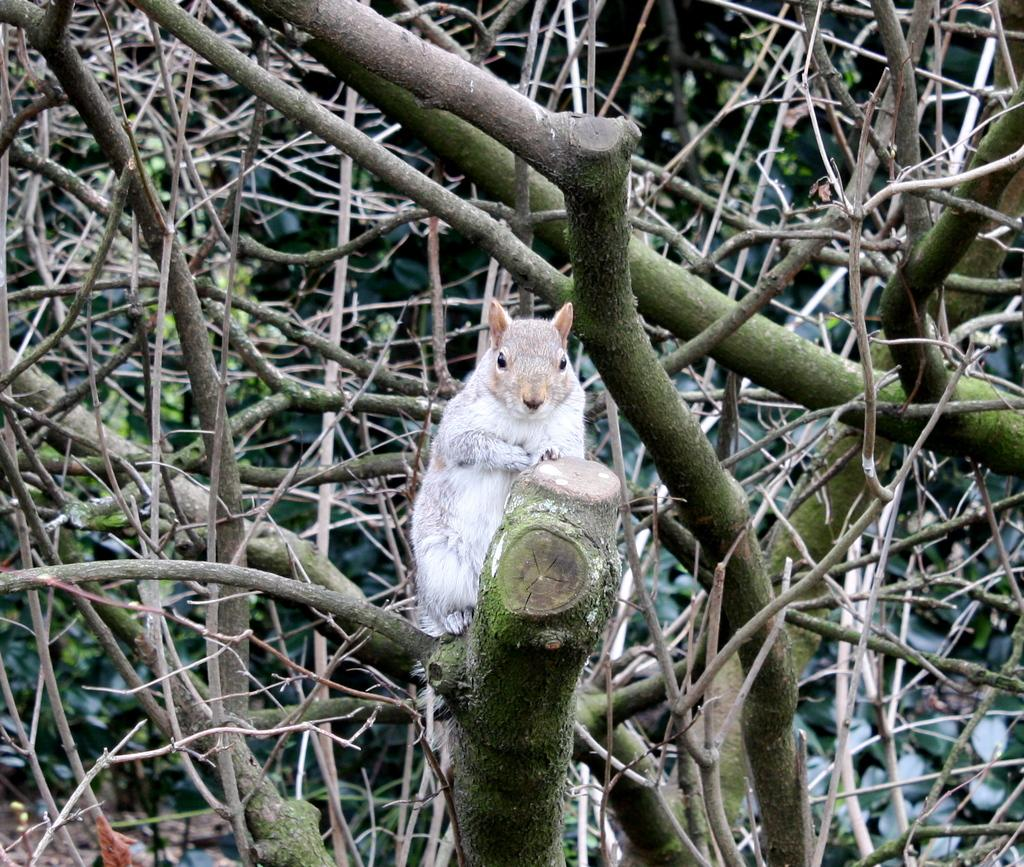What type of animal can be seen in the image? There is an animal in the image, and it is white in color. Where is the animal located in the image? The animal is on a branch of a tree in the image. What else can be seen in the image besides the animal? The tree is visible in the image. What type of wrist accessory is the animal wearing in the image? There is no wrist accessory visible on the animal in the image. What type of drum can be seen in the image? There is no drum present in the image. 